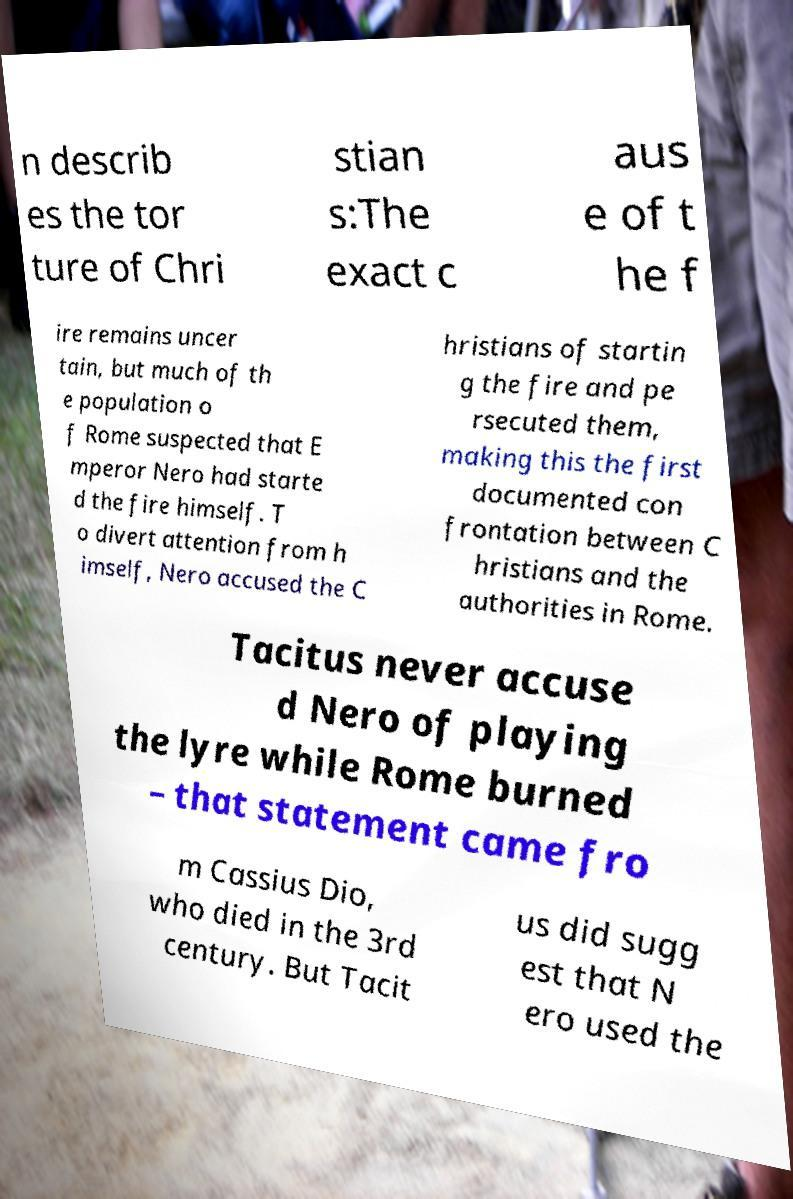Please read and relay the text visible in this image. What does it say? n describ es the tor ture of Chri stian s:The exact c aus e of t he f ire remains uncer tain, but much of th e population o f Rome suspected that E mperor Nero had starte d the fire himself. T o divert attention from h imself, Nero accused the C hristians of startin g the fire and pe rsecuted them, making this the first documented con frontation between C hristians and the authorities in Rome. Tacitus never accuse d Nero of playing the lyre while Rome burned – that statement came fro m Cassius Dio, who died in the 3rd century. But Tacit us did sugg est that N ero used the 